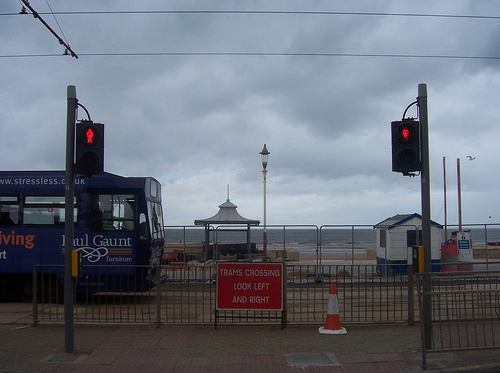Describe the objects in this image and their specific colors. I can see bus in gray, black, and purple tones, traffic light in gray, black, darkgray, navy, and red tones, traffic light in gray, black, maroon, darkgray, and navy tones, people in gray, black, and purple tones, and people in gray and black tones in this image. 